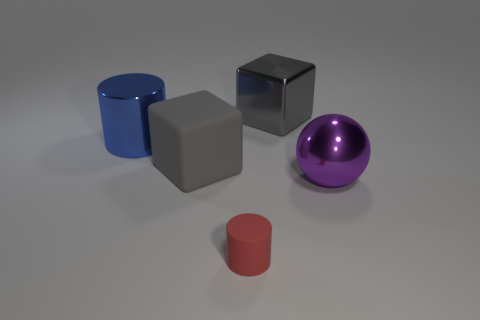What is the thing that is both in front of the large matte thing and behind the small cylinder made of?
Ensure brevity in your answer.  Metal. There is a rubber object that is the same size as the blue metal object; what color is it?
Offer a very short reply. Gray. Are the large cylinder and the block that is in front of the big gray shiny cube made of the same material?
Your answer should be compact. No. How many other things are there of the same size as the shiny cylinder?
Your answer should be compact. 3. There is a cube left of the big block that is to the right of the rubber cylinder; is there a large rubber cube that is to the left of it?
Keep it short and to the point. No. What size is the purple sphere?
Give a very brief answer. Large. There is a cylinder on the left side of the small rubber cylinder; how big is it?
Ensure brevity in your answer.  Large. There is a block on the right side of the red rubber cylinder; does it have the same size as the big metallic ball?
Your response must be concise. Yes. Is there any other thing that is the same color as the large cylinder?
Keep it short and to the point. No. What shape is the big gray matte object?
Give a very brief answer. Cube. 